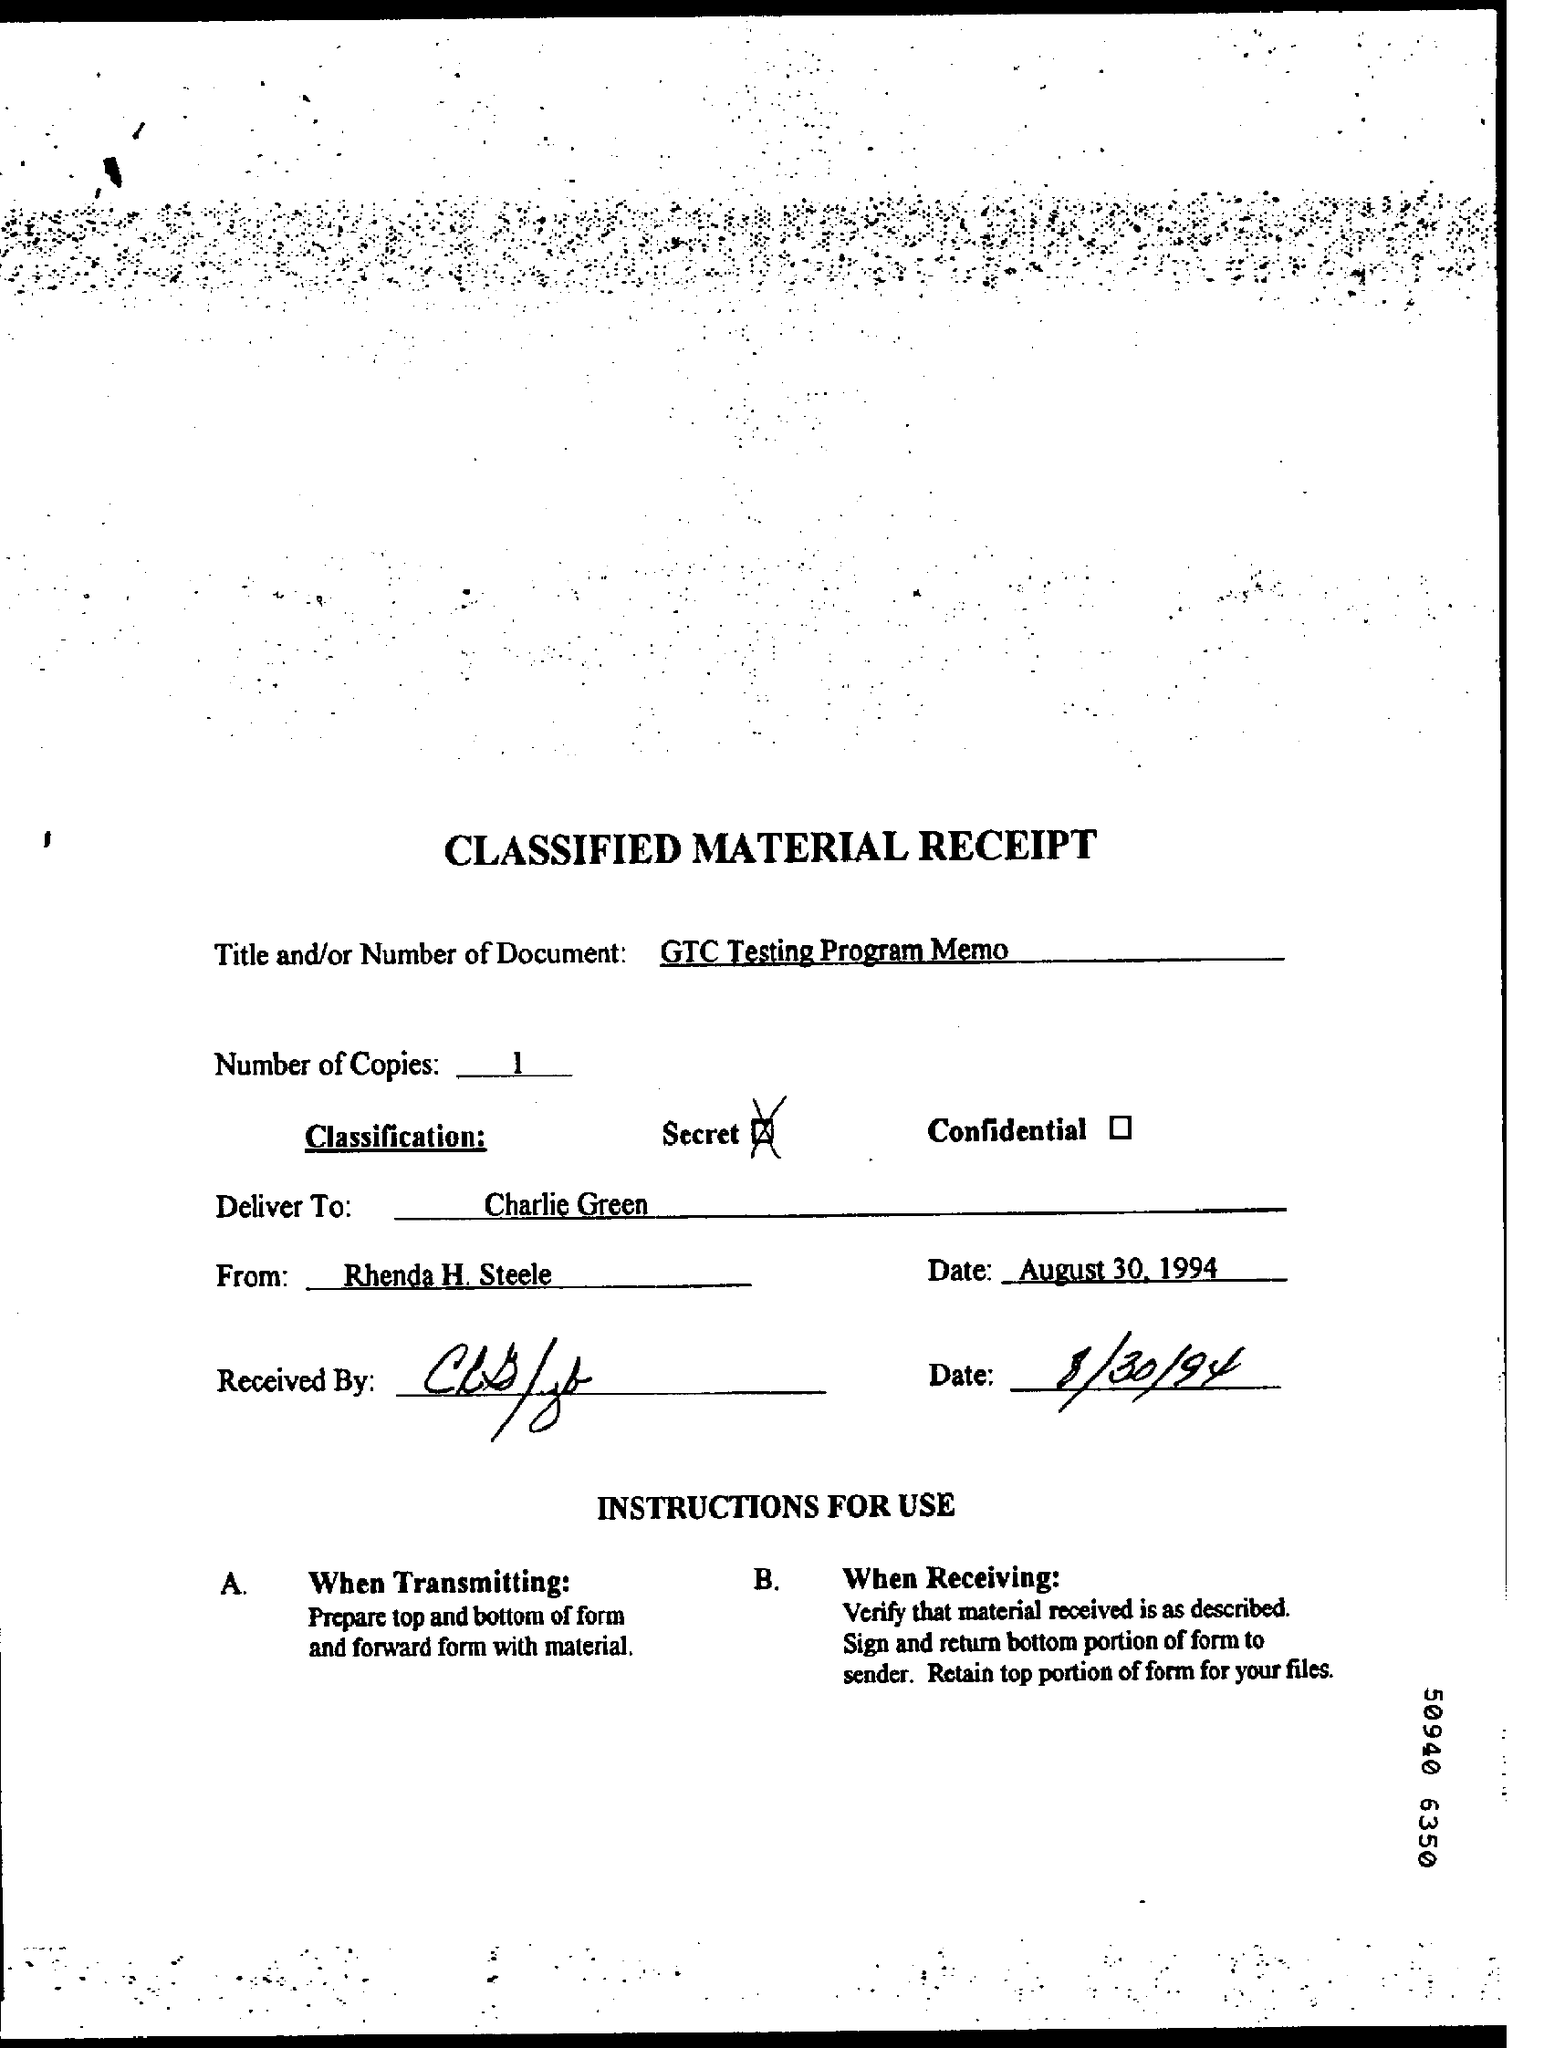Indicate a few pertinent items in this graphic. The sender of this document is Rhenda H. Steele. The classification mentioned in this document is Secret. There are one or more copies mentioned in this text. This document is titled "GTD TESTING PROGRAM MEMO. 